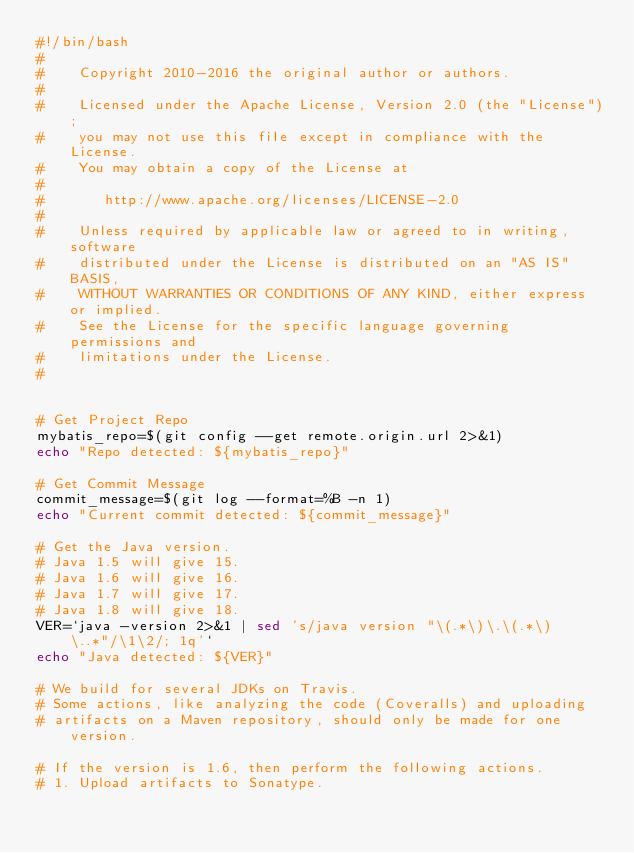<code> <loc_0><loc_0><loc_500><loc_500><_Bash_>#!/bin/bash
#
#    Copyright 2010-2016 the original author or authors.
#
#    Licensed under the Apache License, Version 2.0 (the "License");
#    you may not use this file except in compliance with the License.
#    You may obtain a copy of the License at
#
#       http://www.apache.org/licenses/LICENSE-2.0
#
#    Unless required by applicable law or agreed to in writing, software
#    distributed under the License is distributed on an "AS IS" BASIS,
#    WITHOUT WARRANTIES OR CONDITIONS OF ANY KIND, either express or implied.
#    See the License for the specific language governing permissions and
#    limitations under the License.
#


# Get Project Repo
mybatis_repo=$(git config --get remote.origin.url 2>&1)
echo "Repo detected: ${mybatis_repo}"

# Get Commit Message
commit_message=$(git log --format=%B -n 1)
echo "Current commit detected: ${commit_message}"

# Get the Java version.
# Java 1.5 will give 15.
# Java 1.6 will give 16.
# Java 1.7 will give 17.
# Java 1.8 will give 18.
VER=`java -version 2>&1 | sed 's/java version "\(.*\)\.\(.*\)\..*"/\1\2/; 1q'`
echo "Java detected: ${VER}"

# We build for several JDKs on Travis.
# Some actions, like analyzing the code (Coveralls) and uploading
# artifacts on a Maven repository, should only be made for one version.
 
# If the version is 1.6, then perform the following actions.
# 1. Upload artifacts to Sonatype.</code> 